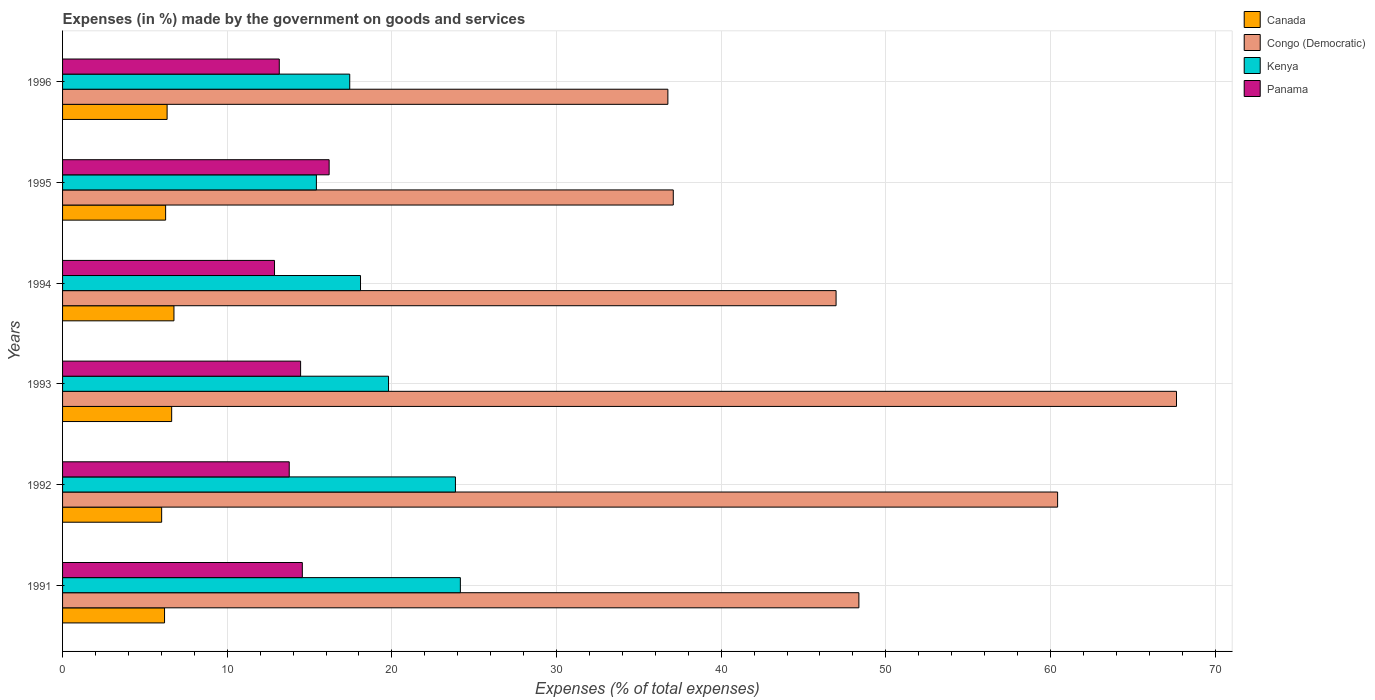Are the number of bars on each tick of the Y-axis equal?
Provide a short and direct response. Yes. How many bars are there on the 3rd tick from the top?
Provide a short and direct response. 4. How many bars are there on the 1st tick from the bottom?
Ensure brevity in your answer.  4. What is the label of the 5th group of bars from the top?
Your response must be concise. 1992. In how many cases, is the number of bars for a given year not equal to the number of legend labels?
Your answer should be very brief. 0. What is the percentage of expenses made by the government on goods and services in Canada in 1994?
Your answer should be very brief. 6.77. Across all years, what is the maximum percentage of expenses made by the government on goods and services in Congo (Democratic)?
Make the answer very short. 67.66. Across all years, what is the minimum percentage of expenses made by the government on goods and services in Kenya?
Keep it short and to the point. 15.42. What is the total percentage of expenses made by the government on goods and services in Congo (Democratic) in the graph?
Provide a succinct answer. 297.29. What is the difference between the percentage of expenses made by the government on goods and services in Kenya in 1993 and that in 1996?
Give a very brief answer. 2.36. What is the difference between the percentage of expenses made by the government on goods and services in Congo (Democratic) in 1996 and the percentage of expenses made by the government on goods and services in Panama in 1995?
Your answer should be very brief. 20.57. What is the average percentage of expenses made by the government on goods and services in Kenya per year?
Your response must be concise. 19.8. In the year 1996, what is the difference between the percentage of expenses made by the government on goods and services in Kenya and percentage of expenses made by the government on goods and services in Congo (Democratic)?
Give a very brief answer. -19.32. In how many years, is the percentage of expenses made by the government on goods and services in Panama greater than 22 %?
Your answer should be very brief. 0. What is the ratio of the percentage of expenses made by the government on goods and services in Canada in 1993 to that in 1995?
Give a very brief answer. 1.06. What is the difference between the highest and the second highest percentage of expenses made by the government on goods and services in Kenya?
Your response must be concise. 0.3. What is the difference between the highest and the lowest percentage of expenses made by the government on goods and services in Kenya?
Your answer should be very brief. 8.74. In how many years, is the percentage of expenses made by the government on goods and services in Panama greater than the average percentage of expenses made by the government on goods and services in Panama taken over all years?
Ensure brevity in your answer.  3. What does the 3rd bar from the top in 1995 represents?
Offer a very short reply. Congo (Democratic). What does the 2nd bar from the bottom in 1994 represents?
Offer a very short reply. Congo (Democratic). What is the difference between two consecutive major ticks on the X-axis?
Your answer should be very brief. 10. Does the graph contain any zero values?
Make the answer very short. No. Does the graph contain grids?
Your answer should be very brief. Yes. Where does the legend appear in the graph?
Keep it short and to the point. Top right. How many legend labels are there?
Offer a very short reply. 4. What is the title of the graph?
Provide a succinct answer. Expenses (in %) made by the government on goods and services. What is the label or title of the X-axis?
Your answer should be very brief. Expenses (% of total expenses). What is the Expenses (% of total expenses) of Canada in 1991?
Provide a succinct answer. 6.19. What is the Expenses (% of total expenses) in Congo (Democratic) in 1991?
Provide a succinct answer. 48.37. What is the Expenses (% of total expenses) of Kenya in 1991?
Your answer should be very brief. 24.16. What is the Expenses (% of total expenses) of Panama in 1991?
Your answer should be compact. 14.56. What is the Expenses (% of total expenses) of Canada in 1992?
Make the answer very short. 6.02. What is the Expenses (% of total expenses) in Congo (Democratic) in 1992?
Make the answer very short. 60.44. What is the Expenses (% of total expenses) in Kenya in 1992?
Give a very brief answer. 23.86. What is the Expenses (% of total expenses) in Panama in 1992?
Provide a succinct answer. 13.77. What is the Expenses (% of total expenses) of Canada in 1993?
Your answer should be compact. 6.63. What is the Expenses (% of total expenses) in Congo (Democratic) in 1993?
Ensure brevity in your answer.  67.66. What is the Expenses (% of total expenses) of Kenya in 1993?
Offer a very short reply. 19.8. What is the Expenses (% of total expenses) of Panama in 1993?
Provide a short and direct response. 14.46. What is the Expenses (% of total expenses) of Canada in 1994?
Your answer should be compact. 6.77. What is the Expenses (% of total expenses) of Congo (Democratic) in 1994?
Your response must be concise. 46.98. What is the Expenses (% of total expenses) of Kenya in 1994?
Provide a short and direct response. 18.1. What is the Expenses (% of total expenses) of Panama in 1994?
Offer a terse response. 12.87. What is the Expenses (% of total expenses) of Canada in 1995?
Keep it short and to the point. 6.26. What is the Expenses (% of total expenses) of Congo (Democratic) in 1995?
Keep it short and to the point. 37.09. What is the Expenses (% of total expenses) in Kenya in 1995?
Ensure brevity in your answer.  15.42. What is the Expenses (% of total expenses) in Panama in 1995?
Provide a succinct answer. 16.19. What is the Expenses (% of total expenses) in Canada in 1996?
Give a very brief answer. 6.35. What is the Expenses (% of total expenses) in Congo (Democratic) in 1996?
Your response must be concise. 36.76. What is the Expenses (% of total expenses) in Kenya in 1996?
Provide a succinct answer. 17.44. What is the Expenses (% of total expenses) in Panama in 1996?
Make the answer very short. 13.16. Across all years, what is the maximum Expenses (% of total expenses) in Canada?
Your answer should be compact. 6.77. Across all years, what is the maximum Expenses (% of total expenses) of Congo (Democratic)?
Provide a short and direct response. 67.66. Across all years, what is the maximum Expenses (% of total expenses) of Kenya?
Give a very brief answer. 24.16. Across all years, what is the maximum Expenses (% of total expenses) in Panama?
Provide a succinct answer. 16.19. Across all years, what is the minimum Expenses (% of total expenses) in Canada?
Provide a short and direct response. 6.02. Across all years, what is the minimum Expenses (% of total expenses) of Congo (Democratic)?
Provide a short and direct response. 36.76. Across all years, what is the minimum Expenses (% of total expenses) of Kenya?
Keep it short and to the point. 15.42. Across all years, what is the minimum Expenses (% of total expenses) in Panama?
Your answer should be compact. 12.87. What is the total Expenses (% of total expenses) of Canada in the graph?
Keep it short and to the point. 38.21. What is the total Expenses (% of total expenses) of Congo (Democratic) in the graph?
Make the answer very short. 297.29. What is the total Expenses (% of total expenses) in Kenya in the graph?
Your answer should be very brief. 118.77. What is the total Expenses (% of total expenses) in Panama in the graph?
Your response must be concise. 85.01. What is the difference between the Expenses (% of total expenses) of Canada in 1991 and that in 1992?
Your answer should be very brief. 0.17. What is the difference between the Expenses (% of total expenses) in Congo (Democratic) in 1991 and that in 1992?
Provide a short and direct response. -12.07. What is the difference between the Expenses (% of total expenses) in Kenya in 1991 and that in 1992?
Ensure brevity in your answer.  0.3. What is the difference between the Expenses (% of total expenses) in Panama in 1991 and that in 1992?
Keep it short and to the point. 0.8. What is the difference between the Expenses (% of total expenses) of Canada in 1991 and that in 1993?
Provide a succinct answer. -0.43. What is the difference between the Expenses (% of total expenses) of Congo (Democratic) in 1991 and that in 1993?
Your answer should be very brief. -19.29. What is the difference between the Expenses (% of total expenses) of Kenya in 1991 and that in 1993?
Provide a succinct answer. 4.36. What is the difference between the Expenses (% of total expenses) in Panama in 1991 and that in 1993?
Ensure brevity in your answer.  0.1. What is the difference between the Expenses (% of total expenses) in Canada in 1991 and that in 1994?
Your response must be concise. -0.57. What is the difference between the Expenses (% of total expenses) in Congo (Democratic) in 1991 and that in 1994?
Ensure brevity in your answer.  1.39. What is the difference between the Expenses (% of total expenses) in Kenya in 1991 and that in 1994?
Keep it short and to the point. 6.06. What is the difference between the Expenses (% of total expenses) of Panama in 1991 and that in 1994?
Your answer should be very brief. 1.69. What is the difference between the Expenses (% of total expenses) of Canada in 1991 and that in 1995?
Make the answer very short. -0.07. What is the difference between the Expenses (% of total expenses) of Congo (Democratic) in 1991 and that in 1995?
Ensure brevity in your answer.  11.27. What is the difference between the Expenses (% of total expenses) in Kenya in 1991 and that in 1995?
Give a very brief answer. 8.74. What is the difference between the Expenses (% of total expenses) of Panama in 1991 and that in 1995?
Keep it short and to the point. -1.63. What is the difference between the Expenses (% of total expenses) of Canada in 1991 and that in 1996?
Offer a very short reply. -0.16. What is the difference between the Expenses (% of total expenses) of Congo (Democratic) in 1991 and that in 1996?
Offer a very short reply. 11.6. What is the difference between the Expenses (% of total expenses) of Kenya in 1991 and that in 1996?
Provide a short and direct response. 6.72. What is the difference between the Expenses (% of total expenses) in Panama in 1991 and that in 1996?
Make the answer very short. 1.4. What is the difference between the Expenses (% of total expenses) in Canada in 1992 and that in 1993?
Offer a terse response. -0.61. What is the difference between the Expenses (% of total expenses) in Congo (Democratic) in 1992 and that in 1993?
Keep it short and to the point. -7.22. What is the difference between the Expenses (% of total expenses) of Kenya in 1992 and that in 1993?
Provide a succinct answer. 4.06. What is the difference between the Expenses (% of total expenses) in Panama in 1992 and that in 1993?
Provide a short and direct response. -0.69. What is the difference between the Expenses (% of total expenses) of Canada in 1992 and that in 1994?
Your response must be concise. -0.75. What is the difference between the Expenses (% of total expenses) in Congo (Democratic) in 1992 and that in 1994?
Keep it short and to the point. 13.46. What is the difference between the Expenses (% of total expenses) of Kenya in 1992 and that in 1994?
Ensure brevity in your answer.  5.76. What is the difference between the Expenses (% of total expenses) in Panama in 1992 and that in 1994?
Offer a terse response. 0.89. What is the difference between the Expenses (% of total expenses) of Canada in 1992 and that in 1995?
Keep it short and to the point. -0.24. What is the difference between the Expenses (% of total expenses) of Congo (Democratic) in 1992 and that in 1995?
Offer a terse response. 23.34. What is the difference between the Expenses (% of total expenses) of Kenya in 1992 and that in 1995?
Make the answer very short. 8.45. What is the difference between the Expenses (% of total expenses) in Panama in 1992 and that in 1995?
Make the answer very short. -2.42. What is the difference between the Expenses (% of total expenses) in Canada in 1992 and that in 1996?
Provide a succinct answer. -0.33. What is the difference between the Expenses (% of total expenses) of Congo (Democratic) in 1992 and that in 1996?
Make the answer very short. 23.67. What is the difference between the Expenses (% of total expenses) of Kenya in 1992 and that in 1996?
Provide a short and direct response. 6.42. What is the difference between the Expenses (% of total expenses) of Panama in 1992 and that in 1996?
Your response must be concise. 0.6. What is the difference between the Expenses (% of total expenses) in Canada in 1993 and that in 1994?
Give a very brief answer. -0.14. What is the difference between the Expenses (% of total expenses) of Congo (Democratic) in 1993 and that in 1994?
Provide a succinct answer. 20.68. What is the difference between the Expenses (% of total expenses) in Kenya in 1993 and that in 1994?
Provide a short and direct response. 1.7. What is the difference between the Expenses (% of total expenses) in Panama in 1993 and that in 1994?
Ensure brevity in your answer.  1.58. What is the difference between the Expenses (% of total expenses) in Canada in 1993 and that in 1995?
Your answer should be compact. 0.37. What is the difference between the Expenses (% of total expenses) of Congo (Democratic) in 1993 and that in 1995?
Your response must be concise. 30.56. What is the difference between the Expenses (% of total expenses) in Kenya in 1993 and that in 1995?
Provide a short and direct response. 4.38. What is the difference between the Expenses (% of total expenses) in Panama in 1993 and that in 1995?
Keep it short and to the point. -1.73. What is the difference between the Expenses (% of total expenses) of Canada in 1993 and that in 1996?
Give a very brief answer. 0.28. What is the difference between the Expenses (% of total expenses) in Congo (Democratic) in 1993 and that in 1996?
Make the answer very short. 30.89. What is the difference between the Expenses (% of total expenses) of Kenya in 1993 and that in 1996?
Provide a succinct answer. 2.36. What is the difference between the Expenses (% of total expenses) in Panama in 1993 and that in 1996?
Provide a short and direct response. 1.3. What is the difference between the Expenses (% of total expenses) in Canada in 1994 and that in 1995?
Offer a very short reply. 0.51. What is the difference between the Expenses (% of total expenses) of Congo (Democratic) in 1994 and that in 1995?
Your answer should be compact. 9.89. What is the difference between the Expenses (% of total expenses) of Kenya in 1994 and that in 1995?
Your answer should be very brief. 2.68. What is the difference between the Expenses (% of total expenses) of Panama in 1994 and that in 1995?
Give a very brief answer. -3.32. What is the difference between the Expenses (% of total expenses) in Canada in 1994 and that in 1996?
Make the answer very short. 0.42. What is the difference between the Expenses (% of total expenses) of Congo (Democratic) in 1994 and that in 1996?
Make the answer very short. 10.22. What is the difference between the Expenses (% of total expenses) in Kenya in 1994 and that in 1996?
Keep it short and to the point. 0.65. What is the difference between the Expenses (% of total expenses) in Panama in 1994 and that in 1996?
Make the answer very short. -0.29. What is the difference between the Expenses (% of total expenses) of Canada in 1995 and that in 1996?
Ensure brevity in your answer.  -0.09. What is the difference between the Expenses (% of total expenses) in Congo (Democratic) in 1995 and that in 1996?
Your answer should be compact. 0.33. What is the difference between the Expenses (% of total expenses) of Kenya in 1995 and that in 1996?
Ensure brevity in your answer.  -2.03. What is the difference between the Expenses (% of total expenses) of Panama in 1995 and that in 1996?
Your answer should be very brief. 3.03. What is the difference between the Expenses (% of total expenses) in Canada in 1991 and the Expenses (% of total expenses) in Congo (Democratic) in 1992?
Your answer should be compact. -54.24. What is the difference between the Expenses (% of total expenses) of Canada in 1991 and the Expenses (% of total expenses) of Kenya in 1992?
Your answer should be compact. -17.67. What is the difference between the Expenses (% of total expenses) in Canada in 1991 and the Expenses (% of total expenses) in Panama in 1992?
Your answer should be compact. -7.57. What is the difference between the Expenses (% of total expenses) of Congo (Democratic) in 1991 and the Expenses (% of total expenses) of Kenya in 1992?
Your answer should be very brief. 24.5. What is the difference between the Expenses (% of total expenses) of Congo (Democratic) in 1991 and the Expenses (% of total expenses) of Panama in 1992?
Keep it short and to the point. 34.6. What is the difference between the Expenses (% of total expenses) in Kenya in 1991 and the Expenses (% of total expenses) in Panama in 1992?
Your response must be concise. 10.39. What is the difference between the Expenses (% of total expenses) of Canada in 1991 and the Expenses (% of total expenses) of Congo (Democratic) in 1993?
Offer a terse response. -61.46. What is the difference between the Expenses (% of total expenses) in Canada in 1991 and the Expenses (% of total expenses) in Kenya in 1993?
Provide a succinct answer. -13.6. What is the difference between the Expenses (% of total expenses) of Canada in 1991 and the Expenses (% of total expenses) of Panama in 1993?
Your answer should be very brief. -8.26. What is the difference between the Expenses (% of total expenses) in Congo (Democratic) in 1991 and the Expenses (% of total expenses) in Kenya in 1993?
Ensure brevity in your answer.  28.57. What is the difference between the Expenses (% of total expenses) of Congo (Democratic) in 1991 and the Expenses (% of total expenses) of Panama in 1993?
Offer a terse response. 33.91. What is the difference between the Expenses (% of total expenses) in Kenya in 1991 and the Expenses (% of total expenses) in Panama in 1993?
Offer a very short reply. 9.7. What is the difference between the Expenses (% of total expenses) in Canada in 1991 and the Expenses (% of total expenses) in Congo (Democratic) in 1994?
Give a very brief answer. -40.79. What is the difference between the Expenses (% of total expenses) of Canada in 1991 and the Expenses (% of total expenses) of Kenya in 1994?
Offer a terse response. -11.9. What is the difference between the Expenses (% of total expenses) of Canada in 1991 and the Expenses (% of total expenses) of Panama in 1994?
Ensure brevity in your answer.  -6.68. What is the difference between the Expenses (% of total expenses) of Congo (Democratic) in 1991 and the Expenses (% of total expenses) of Kenya in 1994?
Ensure brevity in your answer.  30.27. What is the difference between the Expenses (% of total expenses) in Congo (Democratic) in 1991 and the Expenses (% of total expenses) in Panama in 1994?
Keep it short and to the point. 35.49. What is the difference between the Expenses (% of total expenses) in Kenya in 1991 and the Expenses (% of total expenses) in Panama in 1994?
Your response must be concise. 11.29. What is the difference between the Expenses (% of total expenses) of Canada in 1991 and the Expenses (% of total expenses) of Congo (Democratic) in 1995?
Ensure brevity in your answer.  -30.9. What is the difference between the Expenses (% of total expenses) of Canada in 1991 and the Expenses (% of total expenses) of Kenya in 1995?
Your response must be concise. -9.22. What is the difference between the Expenses (% of total expenses) of Canada in 1991 and the Expenses (% of total expenses) of Panama in 1995?
Give a very brief answer. -10. What is the difference between the Expenses (% of total expenses) in Congo (Democratic) in 1991 and the Expenses (% of total expenses) in Kenya in 1995?
Give a very brief answer. 32.95. What is the difference between the Expenses (% of total expenses) in Congo (Democratic) in 1991 and the Expenses (% of total expenses) in Panama in 1995?
Provide a short and direct response. 32.17. What is the difference between the Expenses (% of total expenses) of Kenya in 1991 and the Expenses (% of total expenses) of Panama in 1995?
Give a very brief answer. 7.97. What is the difference between the Expenses (% of total expenses) of Canada in 1991 and the Expenses (% of total expenses) of Congo (Democratic) in 1996?
Ensure brevity in your answer.  -30.57. What is the difference between the Expenses (% of total expenses) in Canada in 1991 and the Expenses (% of total expenses) in Kenya in 1996?
Provide a succinct answer. -11.25. What is the difference between the Expenses (% of total expenses) in Canada in 1991 and the Expenses (% of total expenses) in Panama in 1996?
Your answer should be very brief. -6.97. What is the difference between the Expenses (% of total expenses) of Congo (Democratic) in 1991 and the Expenses (% of total expenses) of Kenya in 1996?
Keep it short and to the point. 30.92. What is the difference between the Expenses (% of total expenses) in Congo (Democratic) in 1991 and the Expenses (% of total expenses) in Panama in 1996?
Give a very brief answer. 35.2. What is the difference between the Expenses (% of total expenses) of Kenya in 1991 and the Expenses (% of total expenses) of Panama in 1996?
Offer a very short reply. 11. What is the difference between the Expenses (% of total expenses) of Canada in 1992 and the Expenses (% of total expenses) of Congo (Democratic) in 1993?
Offer a very short reply. -61.64. What is the difference between the Expenses (% of total expenses) in Canada in 1992 and the Expenses (% of total expenses) in Kenya in 1993?
Provide a succinct answer. -13.78. What is the difference between the Expenses (% of total expenses) in Canada in 1992 and the Expenses (% of total expenses) in Panama in 1993?
Your response must be concise. -8.44. What is the difference between the Expenses (% of total expenses) of Congo (Democratic) in 1992 and the Expenses (% of total expenses) of Kenya in 1993?
Provide a succinct answer. 40.64. What is the difference between the Expenses (% of total expenses) of Congo (Democratic) in 1992 and the Expenses (% of total expenses) of Panama in 1993?
Offer a very short reply. 45.98. What is the difference between the Expenses (% of total expenses) of Kenya in 1992 and the Expenses (% of total expenses) of Panama in 1993?
Your answer should be compact. 9.4. What is the difference between the Expenses (% of total expenses) of Canada in 1992 and the Expenses (% of total expenses) of Congo (Democratic) in 1994?
Ensure brevity in your answer.  -40.96. What is the difference between the Expenses (% of total expenses) in Canada in 1992 and the Expenses (% of total expenses) in Kenya in 1994?
Give a very brief answer. -12.08. What is the difference between the Expenses (% of total expenses) in Canada in 1992 and the Expenses (% of total expenses) in Panama in 1994?
Ensure brevity in your answer.  -6.85. What is the difference between the Expenses (% of total expenses) of Congo (Democratic) in 1992 and the Expenses (% of total expenses) of Kenya in 1994?
Ensure brevity in your answer.  42.34. What is the difference between the Expenses (% of total expenses) in Congo (Democratic) in 1992 and the Expenses (% of total expenses) in Panama in 1994?
Offer a very short reply. 47.56. What is the difference between the Expenses (% of total expenses) in Kenya in 1992 and the Expenses (% of total expenses) in Panama in 1994?
Provide a succinct answer. 10.99. What is the difference between the Expenses (% of total expenses) of Canada in 1992 and the Expenses (% of total expenses) of Congo (Democratic) in 1995?
Provide a short and direct response. -31.07. What is the difference between the Expenses (% of total expenses) of Canada in 1992 and the Expenses (% of total expenses) of Kenya in 1995?
Ensure brevity in your answer.  -9.4. What is the difference between the Expenses (% of total expenses) of Canada in 1992 and the Expenses (% of total expenses) of Panama in 1995?
Your answer should be very brief. -10.17. What is the difference between the Expenses (% of total expenses) of Congo (Democratic) in 1992 and the Expenses (% of total expenses) of Kenya in 1995?
Offer a very short reply. 45.02. What is the difference between the Expenses (% of total expenses) of Congo (Democratic) in 1992 and the Expenses (% of total expenses) of Panama in 1995?
Your response must be concise. 44.24. What is the difference between the Expenses (% of total expenses) in Kenya in 1992 and the Expenses (% of total expenses) in Panama in 1995?
Ensure brevity in your answer.  7.67. What is the difference between the Expenses (% of total expenses) of Canada in 1992 and the Expenses (% of total expenses) of Congo (Democratic) in 1996?
Offer a terse response. -30.75. What is the difference between the Expenses (% of total expenses) of Canada in 1992 and the Expenses (% of total expenses) of Kenya in 1996?
Offer a very short reply. -11.42. What is the difference between the Expenses (% of total expenses) in Canada in 1992 and the Expenses (% of total expenses) in Panama in 1996?
Your response must be concise. -7.14. What is the difference between the Expenses (% of total expenses) in Congo (Democratic) in 1992 and the Expenses (% of total expenses) in Kenya in 1996?
Your answer should be compact. 42.99. What is the difference between the Expenses (% of total expenses) in Congo (Democratic) in 1992 and the Expenses (% of total expenses) in Panama in 1996?
Keep it short and to the point. 47.27. What is the difference between the Expenses (% of total expenses) of Kenya in 1992 and the Expenses (% of total expenses) of Panama in 1996?
Ensure brevity in your answer.  10.7. What is the difference between the Expenses (% of total expenses) of Canada in 1993 and the Expenses (% of total expenses) of Congo (Democratic) in 1994?
Ensure brevity in your answer.  -40.35. What is the difference between the Expenses (% of total expenses) in Canada in 1993 and the Expenses (% of total expenses) in Kenya in 1994?
Give a very brief answer. -11.47. What is the difference between the Expenses (% of total expenses) in Canada in 1993 and the Expenses (% of total expenses) in Panama in 1994?
Offer a terse response. -6.25. What is the difference between the Expenses (% of total expenses) of Congo (Democratic) in 1993 and the Expenses (% of total expenses) of Kenya in 1994?
Ensure brevity in your answer.  49.56. What is the difference between the Expenses (% of total expenses) in Congo (Democratic) in 1993 and the Expenses (% of total expenses) in Panama in 1994?
Ensure brevity in your answer.  54.78. What is the difference between the Expenses (% of total expenses) in Kenya in 1993 and the Expenses (% of total expenses) in Panama in 1994?
Your answer should be very brief. 6.93. What is the difference between the Expenses (% of total expenses) of Canada in 1993 and the Expenses (% of total expenses) of Congo (Democratic) in 1995?
Provide a short and direct response. -30.47. What is the difference between the Expenses (% of total expenses) of Canada in 1993 and the Expenses (% of total expenses) of Kenya in 1995?
Give a very brief answer. -8.79. What is the difference between the Expenses (% of total expenses) of Canada in 1993 and the Expenses (% of total expenses) of Panama in 1995?
Keep it short and to the point. -9.56. What is the difference between the Expenses (% of total expenses) of Congo (Democratic) in 1993 and the Expenses (% of total expenses) of Kenya in 1995?
Make the answer very short. 52.24. What is the difference between the Expenses (% of total expenses) of Congo (Democratic) in 1993 and the Expenses (% of total expenses) of Panama in 1995?
Your answer should be very brief. 51.47. What is the difference between the Expenses (% of total expenses) of Kenya in 1993 and the Expenses (% of total expenses) of Panama in 1995?
Offer a terse response. 3.61. What is the difference between the Expenses (% of total expenses) of Canada in 1993 and the Expenses (% of total expenses) of Congo (Democratic) in 1996?
Offer a very short reply. -30.14. What is the difference between the Expenses (% of total expenses) of Canada in 1993 and the Expenses (% of total expenses) of Kenya in 1996?
Provide a short and direct response. -10.81. What is the difference between the Expenses (% of total expenses) in Canada in 1993 and the Expenses (% of total expenses) in Panama in 1996?
Your response must be concise. -6.54. What is the difference between the Expenses (% of total expenses) of Congo (Democratic) in 1993 and the Expenses (% of total expenses) of Kenya in 1996?
Your response must be concise. 50.21. What is the difference between the Expenses (% of total expenses) of Congo (Democratic) in 1993 and the Expenses (% of total expenses) of Panama in 1996?
Provide a short and direct response. 54.49. What is the difference between the Expenses (% of total expenses) of Kenya in 1993 and the Expenses (% of total expenses) of Panama in 1996?
Make the answer very short. 6.64. What is the difference between the Expenses (% of total expenses) of Canada in 1994 and the Expenses (% of total expenses) of Congo (Democratic) in 1995?
Offer a very short reply. -30.33. What is the difference between the Expenses (% of total expenses) in Canada in 1994 and the Expenses (% of total expenses) in Kenya in 1995?
Offer a very short reply. -8.65. What is the difference between the Expenses (% of total expenses) of Canada in 1994 and the Expenses (% of total expenses) of Panama in 1995?
Ensure brevity in your answer.  -9.43. What is the difference between the Expenses (% of total expenses) in Congo (Democratic) in 1994 and the Expenses (% of total expenses) in Kenya in 1995?
Offer a very short reply. 31.56. What is the difference between the Expenses (% of total expenses) in Congo (Democratic) in 1994 and the Expenses (% of total expenses) in Panama in 1995?
Ensure brevity in your answer.  30.79. What is the difference between the Expenses (% of total expenses) in Kenya in 1994 and the Expenses (% of total expenses) in Panama in 1995?
Make the answer very short. 1.91. What is the difference between the Expenses (% of total expenses) in Canada in 1994 and the Expenses (% of total expenses) in Congo (Democratic) in 1996?
Keep it short and to the point. -30. What is the difference between the Expenses (% of total expenses) in Canada in 1994 and the Expenses (% of total expenses) in Kenya in 1996?
Your answer should be compact. -10.68. What is the difference between the Expenses (% of total expenses) in Canada in 1994 and the Expenses (% of total expenses) in Panama in 1996?
Ensure brevity in your answer.  -6.4. What is the difference between the Expenses (% of total expenses) in Congo (Democratic) in 1994 and the Expenses (% of total expenses) in Kenya in 1996?
Provide a short and direct response. 29.54. What is the difference between the Expenses (% of total expenses) in Congo (Democratic) in 1994 and the Expenses (% of total expenses) in Panama in 1996?
Ensure brevity in your answer.  33.82. What is the difference between the Expenses (% of total expenses) in Kenya in 1994 and the Expenses (% of total expenses) in Panama in 1996?
Ensure brevity in your answer.  4.93. What is the difference between the Expenses (% of total expenses) of Canada in 1995 and the Expenses (% of total expenses) of Congo (Democratic) in 1996?
Ensure brevity in your answer.  -30.5. What is the difference between the Expenses (% of total expenses) in Canada in 1995 and the Expenses (% of total expenses) in Kenya in 1996?
Offer a very short reply. -11.18. What is the difference between the Expenses (% of total expenses) of Canada in 1995 and the Expenses (% of total expenses) of Panama in 1996?
Offer a terse response. -6.9. What is the difference between the Expenses (% of total expenses) in Congo (Democratic) in 1995 and the Expenses (% of total expenses) in Kenya in 1996?
Give a very brief answer. 19.65. What is the difference between the Expenses (% of total expenses) in Congo (Democratic) in 1995 and the Expenses (% of total expenses) in Panama in 1996?
Provide a short and direct response. 23.93. What is the difference between the Expenses (% of total expenses) of Kenya in 1995 and the Expenses (% of total expenses) of Panama in 1996?
Give a very brief answer. 2.25. What is the average Expenses (% of total expenses) of Canada per year?
Offer a terse response. 6.37. What is the average Expenses (% of total expenses) of Congo (Democratic) per year?
Your answer should be compact. 49.55. What is the average Expenses (% of total expenses) of Kenya per year?
Your response must be concise. 19.8. What is the average Expenses (% of total expenses) in Panama per year?
Provide a short and direct response. 14.17. In the year 1991, what is the difference between the Expenses (% of total expenses) in Canada and Expenses (% of total expenses) in Congo (Democratic)?
Your answer should be very brief. -42.17. In the year 1991, what is the difference between the Expenses (% of total expenses) of Canada and Expenses (% of total expenses) of Kenya?
Offer a very short reply. -17.97. In the year 1991, what is the difference between the Expenses (% of total expenses) in Canada and Expenses (% of total expenses) in Panama?
Your response must be concise. -8.37. In the year 1991, what is the difference between the Expenses (% of total expenses) of Congo (Democratic) and Expenses (% of total expenses) of Kenya?
Give a very brief answer. 24.21. In the year 1991, what is the difference between the Expenses (% of total expenses) of Congo (Democratic) and Expenses (% of total expenses) of Panama?
Your answer should be very brief. 33.8. In the year 1991, what is the difference between the Expenses (% of total expenses) of Kenya and Expenses (% of total expenses) of Panama?
Offer a terse response. 9.6. In the year 1992, what is the difference between the Expenses (% of total expenses) of Canada and Expenses (% of total expenses) of Congo (Democratic)?
Ensure brevity in your answer.  -54.42. In the year 1992, what is the difference between the Expenses (% of total expenses) of Canada and Expenses (% of total expenses) of Kenya?
Your answer should be compact. -17.84. In the year 1992, what is the difference between the Expenses (% of total expenses) in Canada and Expenses (% of total expenses) in Panama?
Make the answer very short. -7.75. In the year 1992, what is the difference between the Expenses (% of total expenses) in Congo (Democratic) and Expenses (% of total expenses) in Kenya?
Offer a terse response. 36.57. In the year 1992, what is the difference between the Expenses (% of total expenses) in Congo (Democratic) and Expenses (% of total expenses) in Panama?
Your answer should be compact. 46.67. In the year 1992, what is the difference between the Expenses (% of total expenses) in Kenya and Expenses (% of total expenses) in Panama?
Provide a short and direct response. 10.09. In the year 1993, what is the difference between the Expenses (% of total expenses) of Canada and Expenses (% of total expenses) of Congo (Democratic)?
Keep it short and to the point. -61.03. In the year 1993, what is the difference between the Expenses (% of total expenses) of Canada and Expenses (% of total expenses) of Kenya?
Provide a succinct answer. -13.17. In the year 1993, what is the difference between the Expenses (% of total expenses) in Canada and Expenses (% of total expenses) in Panama?
Make the answer very short. -7.83. In the year 1993, what is the difference between the Expenses (% of total expenses) of Congo (Democratic) and Expenses (% of total expenses) of Kenya?
Give a very brief answer. 47.86. In the year 1993, what is the difference between the Expenses (% of total expenses) in Congo (Democratic) and Expenses (% of total expenses) in Panama?
Ensure brevity in your answer.  53.2. In the year 1993, what is the difference between the Expenses (% of total expenses) of Kenya and Expenses (% of total expenses) of Panama?
Your answer should be compact. 5.34. In the year 1994, what is the difference between the Expenses (% of total expenses) in Canada and Expenses (% of total expenses) in Congo (Democratic)?
Keep it short and to the point. -40.21. In the year 1994, what is the difference between the Expenses (% of total expenses) of Canada and Expenses (% of total expenses) of Kenya?
Offer a very short reply. -11.33. In the year 1994, what is the difference between the Expenses (% of total expenses) in Canada and Expenses (% of total expenses) in Panama?
Keep it short and to the point. -6.11. In the year 1994, what is the difference between the Expenses (% of total expenses) of Congo (Democratic) and Expenses (% of total expenses) of Kenya?
Your answer should be very brief. 28.88. In the year 1994, what is the difference between the Expenses (% of total expenses) of Congo (Democratic) and Expenses (% of total expenses) of Panama?
Ensure brevity in your answer.  34.11. In the year 1994, what is the difference between the Expenses (% of total expenses) of Kenya and Expenses (% of total expenses) of Panama?
Your answer should be compact. 5.22. In the year 1995, what is the difference between the Expenses (% of total expenses) of Canada and Expenses (% of total expenses) of Congo (Democratic)?
Give a very brief answer. -30.83. In the year 1995, what is the difference between the Expenses (% of total expenses) in Canada and Expenses (% of total expenses) in Kenya?
Your response must be concise. -9.16. In the year 1995, what is the difference between the Expenses (% of total expenses) in Canada and Expenses (% of total expenses) in Panama?
Keep it short and to the point. -9.93. In the year 1995, what is the difference between the Expenses (% of total expenses) of Congo (Democratic) and Expenses (% of total expenses) of Kenya?
Offer a terse response. 21.68. In the year 1995, what is the difference between the Expenses (% of total expenses) of Congo (Democratic) and Expenses (% of total expenses) of Panama?
Provide a succinct answer. 20.9. In the year 1995, what is the difference between the Expenses (% of total expenses) in Kenya and Expenses (% of total expenses) in Panama?
Your response must be concise. -0.77. In the year 1996, what is the difference between the Expenses (% of total expenses) in Canada and Expenses (% of total expenses) in Congo (Democratic)?
Ensure brevity in your answer.  -30.41. In the year 1996, what is the difference between the Expenses (% of total expenses) in Canada and Expenses (% of total expenses) in Kenya?
Provide a succinct answer. -11.09. In the year 1996, what is the difference between the Expenses (% of total expenses) in Canada and Expenses (% of total expenses) in Panama?
Offer a very short reply. -6.81. In the year 1996, what is the difference between the Expenses (% of total expenses) in Congo (Democratic) and Expenses (% of total expenses) in Kenya?
Ensure brevity in your answer.  19.32. In the year 1996, what is the difference between the Expenses (% of total expenses) in Congo (Democratic) and Expenses (% of total expenses) in Panama?
Provide a succinct answer. 23.6. In the year 1996, what is the difference between the Expenses (% of total expenses) in Kenya and Expenses (% of total expenses) in Panama?
Provide a succinct answer. 4.28. What is the ratio of the Expenses (% of total expenses) in Canada in 1991 to that in 1992?
Your answer should be very brief. 1.03. What is the ratio of the Expenses (% of total expenses) of Congo (Democratic) in 1991 to that in 1992?
Your answer should be very brief. 0.8. What is the ratio of the Expenses (% of total expenses) in Kenya in 1991 to that in 1992?
Provide a short and direct response. 1.01. What is the ratio of the Expenses (% of total expenses) in Panama in 1991 to that in 1992?
Offer a terse response. 1.06. What is the ratio of the Expenses (% of total expenses) in Canada in 1991 to that in 1993?
Offer a very short reply. 0.93. What is the ratio of the Expenses (% of total expenses) of Congo (Democratic) in 1991 to that in 1993?
Offer a terse response. 0.71. What is the ratio of the Expenses (% of total expenses) in Kenya in 1991 to that in 1993?
Make the answer very short. 1.22. What is the ratio of the Expenses (% of total expenses) in Canada in 1991 to that in 1994?
Your answer should be very brief. 0.92. What is the ratio of the Expenses (% of total expenses) in Congo (Democratic) in 1991 to that in 1994?
Provide a succinct answer. 1.03. What is the ratio of the Expenses (% of total expenses) in Kenya in 1991 to that in 1994?
Give a very brief answer. 1.34. What is the ratio of the Expenses (% of total expenses) of Panama in 1991 to that in 1994?
Your answer should be compact. 1.13. What is the ratio of the Expenses (% of total expenses) of Congo (Democratic) in 1991 to that in 1995?
Your response must be concise. 1.3. What is the ratio of the Expenses (% of total expenses) of Kenya in 1991 to that in 1995?
Keep it short and to the point. 1.57. What is the ratio of the Expenses (% of total expenses) in Panama in 1991 to that in 1995?
Give a very brief answer. 0.9. What is the ratio of the Expenses (% of total expenses) of Canada in 1991 to that in 1996?
Your answer should be very brief. 0.98. What is the ratio of the Expenses (% of total expenses) in Congo (Democratic) in 1991 to that in 1996?
Provide a succinct answer. 1.32. What is the ratio of the Expenses (% of total expenses) in Kenya in 1991 to that in 1996?
Ensure brevity in your answer.  1.39. What is the ratio of the Expenses (% of total expenses) of Panama in 1991 to that in 1996?
Your response must be concise. 1.11. What is the ratio of the Expenses (% of total expenses) in Canada in 1992 to that in 1993?
Your answer should be very brief. 0.91. What is the ratio of the Expenses (% of total expenses) of Congo (Democratic) in 1992 to that in 1993?
Keep it short and to the point. 0.89. What is the ratio of the Expenses (% of total expenses) in Kenya in 1992 to that in 1993?
Provide a succinct answer. 1.21. What is the ratio of the Expenses (% of total expenses) in Panama in 1992 to that in 1993?
Keep it short and to the point. 0.95. What is the ratio of the Expenses (% of total expenses) in Canada in 1992 to that in 1994?
Provide a succinct answer. 0.89. What is the ratio of the Expenses (% of total expenses) of Congo (Democratic) in 1992 to that in 1994?
Give a very brief answer. 1.29. What is the ratio of the Expenses (% of total expenses) in Kenya in 1992 to that in 1994?
Make the answer very short. 1.32. What is the ratio of the Expenses (% of total expenses) of Panama in 1992 to that in 1994?
Offer a very short reply. 1.07. What is the ratio of the Expenses (% of total expenses) of Canada in 1992 to that in 1995?
Provide a succinct answer. 0.96. What is the ratio of the Expenses (% of total expenses) of Congo (Democratic) in 1992 to that in 1995?
Give a very brief answer. 1.63. What is the ratio of the Expenses (% of total expenses) of Kenya in 1992 to that in 1995?
Make the answer very short. 1.55. What is the ratio of the Expenses (% of total expenses) of Panama in 1992 to that in 1995?
Your response must be concise. 0.85. What is the ratio of the Expenses (% of total expenses) in Canada in 1992 to that in 1996?
Provide a succinct answer. 0.95. What is the ratio of the Expenses (% of total expenses) in Congo (Democratic) in 1992 to that in 1996?
Give a very brief answer. 1.64. What is the ratio of the Expenses (% of total expenses) in Kenya in 1992 to that in 1996?
Offer a very short reply. 1.37. What is the ratio of the Expenses (% of total expenses) in Panama in 1992 to that in 1996?
Your answer should be very brief. 1.05. What is the ratio of the Expenses (% of total expenses) of Canada in 1993 to that in 1994?
Provide a short and direct response. 0.98. What is the ratio of the Expenses (% of total expenses) in Congo (Democratic) in 1993 to that in 1994?
Your answer should be very brief. 1.44. What is the ratio of the Expenses (% of total expenses) of Kenya in 1993 to that in 1994?
Provide a short and direct response. 1.09. What is the ratio of the Expenses (% of total expenses) in Panama in 1993 to that in 1994?
Your answer should be compact. 1.12. What is the ratio of the Expenses (% of total expenses) in Canada in 1993 to that in 1995?
Provide a short and direct response. 1.06. What is the ratio of the Expenses (% of total expenses) in Congo (Democratic) in 1993 to that in 1995?
Make the answer very short. 1.82. What is the ratio of the Expenses (% of total expenses) of Kenya in 1993 to that in 1995?
Provide a short and direct response. 1.28. What is the ratio of the Expenses (% of total expenses) of Panama in 1993 to that in 1995?
Provide a short and direct response. 0.89. What is the ratio of the Expenses (% of total expenses) in Canada in 1993 to that in 1996?
Make the answer very short. 1.04. What is the ratio of the Expenses (% of total expenses) of Congo (Democratic) in 1993 to that in 1996?
Keep it short and to the point. 1.84. What is the ratio of the Expenses (% of total expenses) of Kenya in 1993 to that in 1996?
Offer a terse response. 1.14. What is the ratio of the Expenses (% of total expenses) in Panama in 1993 to that in 1996?
Offer a very short reply. 1.1. What is the ratio of the Expenses (% of total expenses) of Canada in 1994 to that in 1995?
Make the answer very short. 1.08. What is the ratio of the Expenses (% of total expenses) in Congo (Democratic) in 1994 to that in 1995?
Offer a terse response. 1.27. What is the ratio of the Expenses (% of total expenses) of Kenya in 1994 to that in 1995?
Offer a very short reply. 1.17. What is the ratio of the Expenses (% of total expenses) of Panama in 1994 to that in 1995?
Offer a very short reply. 0.8. What is the ratio of the Expenses (% of total expenses) in Canada in 1994 to that in 1996?
Provide a short and direct response. 1.07. What is the ratio of the Expenses (% of total expenses) of Congo (Democratic) in 1994 to that in 1996?
Your response must be concise. 1.28. What is the ratio of the Expenses (% of total expenses) in Kenya in 1994 to that in 1996?
Keep it short and to the point. 1.04. What is the ratio of the Expenses (% of total expenses) in Panama in 1994 to that in 1996?
Offer a terse response. 0.98. What is the ratio of the Expenses (% of total expenses) in Canada in 1995 to that in 1996?
Your response must be concise. 0.99. What is the ratio of the Expenses (% of total expenses) in Kenya in 1995 to that in 1996?
Your response must be concise. 0.88. What is the ratio of the Expenses (% of total expenses) of Panama in 1995 to that in 1996?
Provide a succinct answer. 1.23. What is the difference between the highest and the second highest Expenses (% of total expenses) in Canada?
Offer a terse response. 0.14. What is the difference between the highest and the second highest Expenses (% of total expenses) of Congo (Democratic)?
Give a very brief answer. 7.22. What is the difference between the highest and the second highest Expenses (% of total expenses) in Kenya?
Ensure brevity in your answer.  0.3. What is the difference between the highest and the second highest Expenses (% of total expenses) in Panama?
Offer a very short reply. 1.63. What is the difference between the highest and the lowest Expenses (% of total expenses) of Canada?
Provide a succinct answer. 0.75. What is the difference between the highest and the lowest Expenses (% of total expenses) of Congo (Democratic)?
Offer a very short reply. 30.89. What is the difference between the highest and the lowest Expenses (% of total expenses) in Kenya?
Keep it short and to the point. 8.74. What is the difference between the highest and the lowest Expenses (% of total expenses) in Panama?
Your response must be concise. 3.32. 